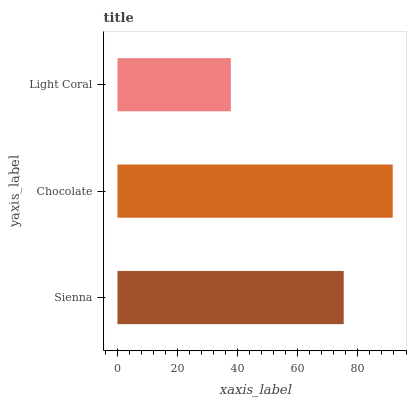Is Light Coral the minimum?
Answer yes or no. Yes. Is Chocolate the maximum?
Answer yes or no. Yes. Is Chocolate the minimum?
Answer yes or no. No. Is Light Coral the maximum?
Answer yes or no. No. Is Chocolate greater than Light Coral?
Answer yes or no. Yes. Is Light Coral less than Chocolate?
Answer yes or no. Yes. Is Light Coral greater than Chocolate?
Answer yes or no. No. Is Chocolate less than Light Coral?
Answer yes or no. No. Is Sienna the high median?
Answer yes or no. Yes. Is Sienna the low median?
Answer yes or no. Yes. Is Light Coral the high median?
Answer yes or no. No. Is Light Coral the low median?
Answer yes or no. No. 